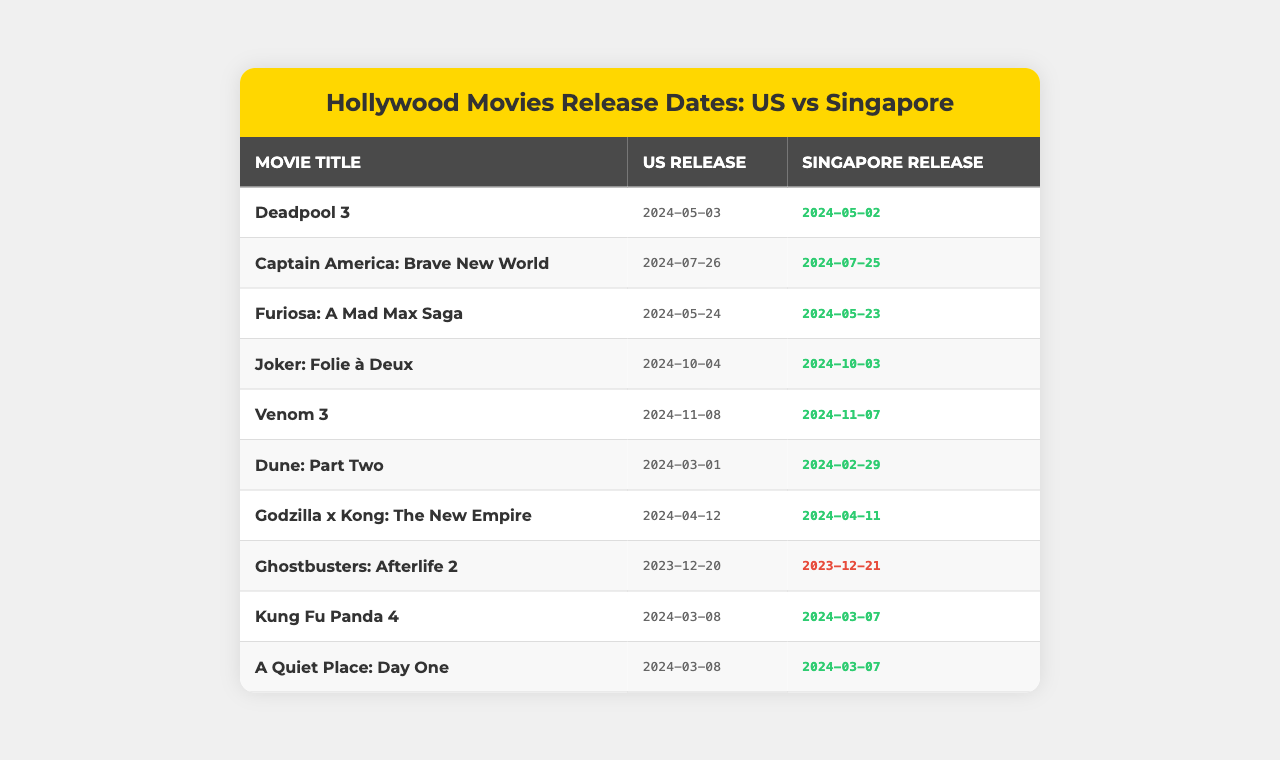What is the release date of "Deadpool 3" in Singapore? The table shows that "Deadpool 3" has a release date of 2024-05-02 in Singapore.
Answer: 2024-05-02 How many days earlier is the Singapore release of "Furiosa: A Mad Max Saga" compared to the US release? The US release date of "Furiosa: A Mad Max Saga" is 2024-05-24 and the Singapore release is 2024-05-23. The Singapore release is one day earlier.
Answer: 1 day Is the Singapore release date for "Ghostbusters: Afterlife 2" earlier or later than the US release? The table indicates that the US release is on 2023-12-20 and the Singapore release is on 2023-12-21, thus Singapore's release is later.
Answer: Later How many movies are released in Singapore one day earlier than in the US? Looking at the table, "Deadpool 3," "Captain America: Brave New World," "Furiosa: A Mad Max Saga," "Joker: Folie à Deux," "Venom 3," "Dune: Part Two," "Godzilla x Kong: The New Empire," "Kung Fu Panda 4," and "A Quiet Place: Day One" all have a release one day earlier. Counting them gives us a total of 7 movies.
Answer: 7 movies What is the difference in release dates between "Dune: Part Two" in the US and Singapore? The US release date of "Dune: Part Two" is 2024-03-01, and the Singapore release is 2024-02-29. Since Singapore's release is one day earlier, the difference is one day regarding the release trend.
Answer: 1 day Which movie has the latest release date in Singapore? The latest Singapore release date on the table is for "Joker: Folie à Deux," which is on 2024-10-03.
Answer: "Joker: Folie à Deux" Are there any movies that have the same release date in both Singapore and the US? By examining the table, it can be seen that there are no movies listed with the same release date in both countries. Thus, the answer is no.
Answer: No Which movie has the same release day as "Kung Fu Panda 4" in Singapore? The table shows that "A Quiet Place: Day One" has a release date of 2024-03-07, which is the same as "Kung Fu Panda 4."
Answer: "A Quiet Place: Day One" Is there a movie that releases on the same date in Singapore and the US in 2024? After checking the table, it is clear that there are no movies that release on the same date in 2024.
Answer: No 